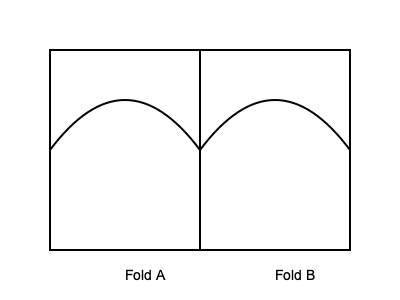If you were to create a 3D pop-up of Luisa Sonza's signature voluminous curly hairstyle by folding a rectangular paper, which fold pattern would you use to achieve the desired effect, as shown in the diagram? To create a 3D pop-up of Luisa Sonza's signature voluminous curly hairstyle, we need to consider the following steps:

1. Luisa Sonza is known for her big, bouncy curls that frame her face.
2. The diagram shows two folding patterns: Fold A and Fold B.
3. Fold A creates a curved, dome-like shape when the paper is opened at a 90-degree angle.
4. Fold B is a mirror image of Fold A, creating a symmetrical curved shape.
5. To achieve a voluminous, curly effect, we need both folds to work together.
6. By using both Fold A and Fold B, we create two curved sections that, when opened, will pop up to form a 3D representation of voluminous, curly hair.
7. The symmetry of the folds ensures that the hairstyle will appear balanced and frame the face evenly on both sides.
8. The curved nature of the folds mimics the natural curve of curly hair, giving a more realistic representation of Luisa Sonza's signature look.

Therefore, to achieve the desired 3D pop-up effect of Luisa Sonza's voluminous curly hairstyle, we would use both Fold A and Fold B together.
Answer: Both Fold A and Fold B 